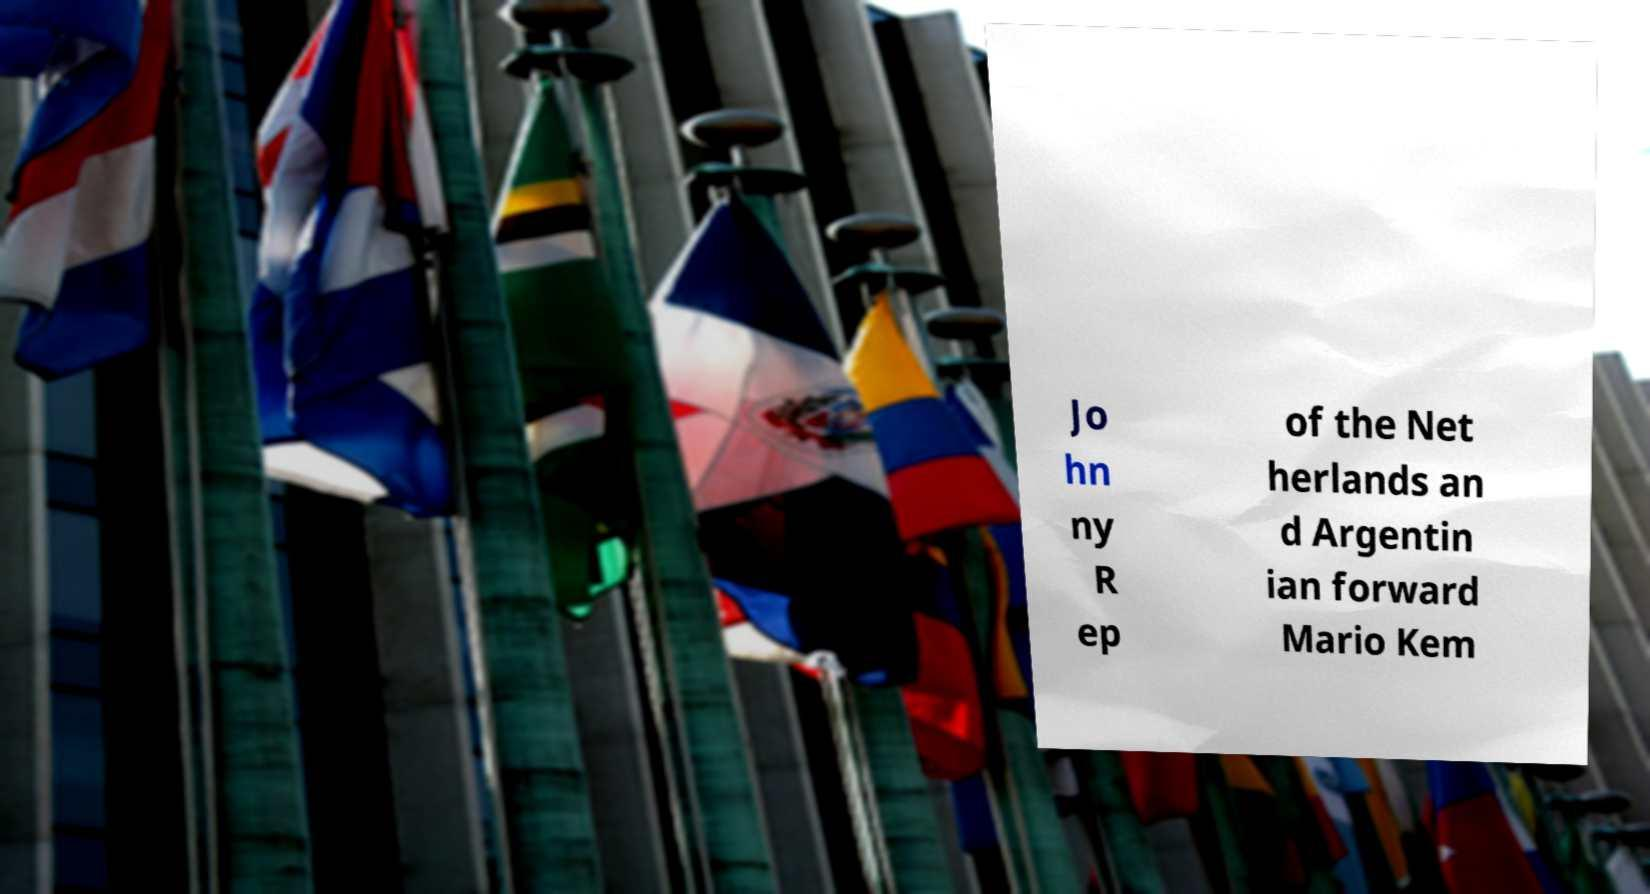There's text embedded in this image that I need extracted. Can you transcribe it verbatim? Jo hn ny R ep of the Net herlands an d Argentin ian forward Mario Kem 